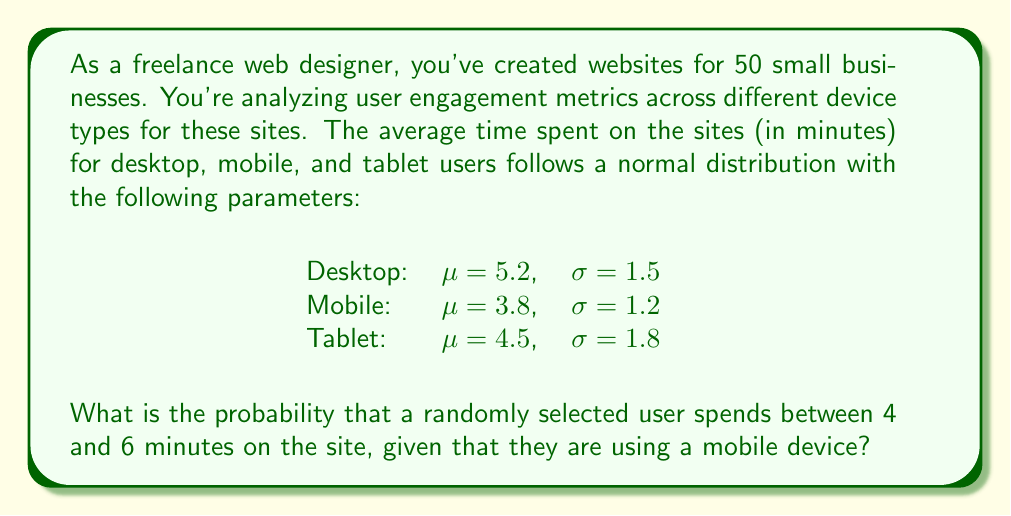Can you answer this question? To solve this problem, we need to use the properties of the normal distribution and standardize our values.

1. For mobile users, we have $\mu = 3.8$ and $\sigma = 1.2$.

2. We need to find $P(4 \leq X \leq 6)$ for mobile users.

3. To standardize, we use the z-score formula:
   $z = \frac{x - \mu}{\sigma}$

4. Calculate z-scores for the lower and upper bounds:
   $z_1 = \frac{4 - 3.8}{1.2} = 0.1667$
   $z_2 = \frac{6 - 3.8}{1.2} = 1.8333$

5. Now we need to find $P(0.1667 \leq Z \leq 1.8333)$

6. Using a standard normal distribution table or calculator:
   $P(Z \leq 1.8333) = 0.9666$
   $P(Z \leq 0.1667) = 0.5662$

7. The probability is the difference between these values:
   $P(0.1667 \leq Z \leq 1.8333) = 0.9666 - 0.5662 = 0.4004$

Therefore, the probability is approximately 0.4004 or 40.04%.
Answer: The probability that a randomly selected mobile user spends between 4 and 6 minutes on the site is approximately 0.4004 or 40.04%. 